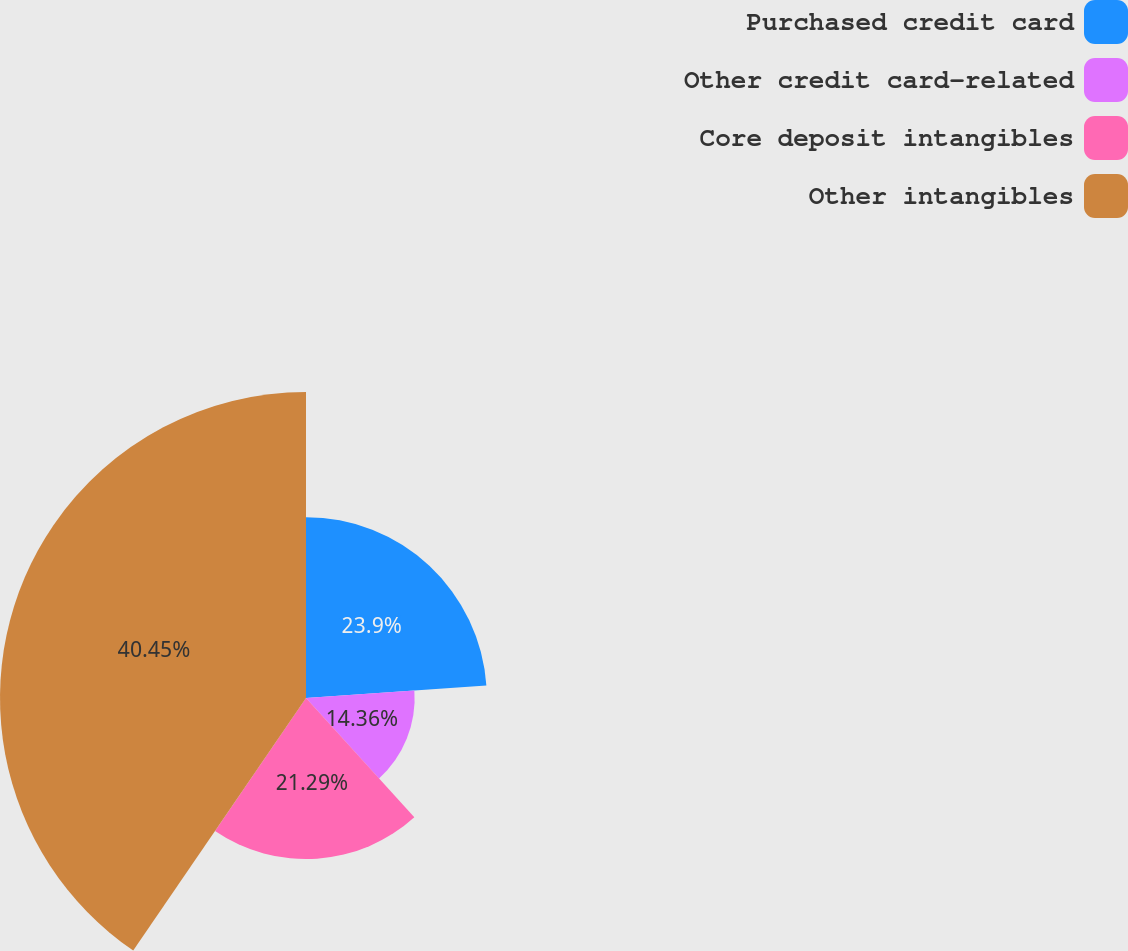Convert chart. <chart><loc_0><loc_0><loc_500><loc_500><pie_chart><fcel>Purchased credit card<fcel>Other credit card-related<fcel>Core deposit intangibles<fcel>Other intangibles<nl><fcel>23.9%<fcel>14.36%<fcel>21.29%<fcel>40.45%<nl></chart> 